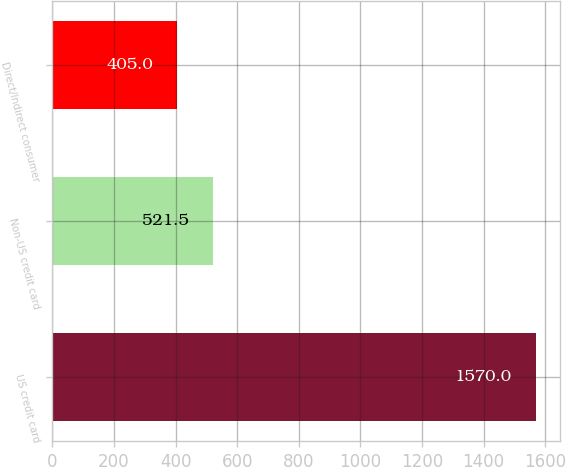<chart> <loc_0><loc_0><loc_500><loc_500><bar_chart><fcel>US credit card<fcel>Non-US credit card<fcel>Direct/Indirect consumer<nl><fcel>1570<fcel>521.5<fcel>405<nl></chart> 